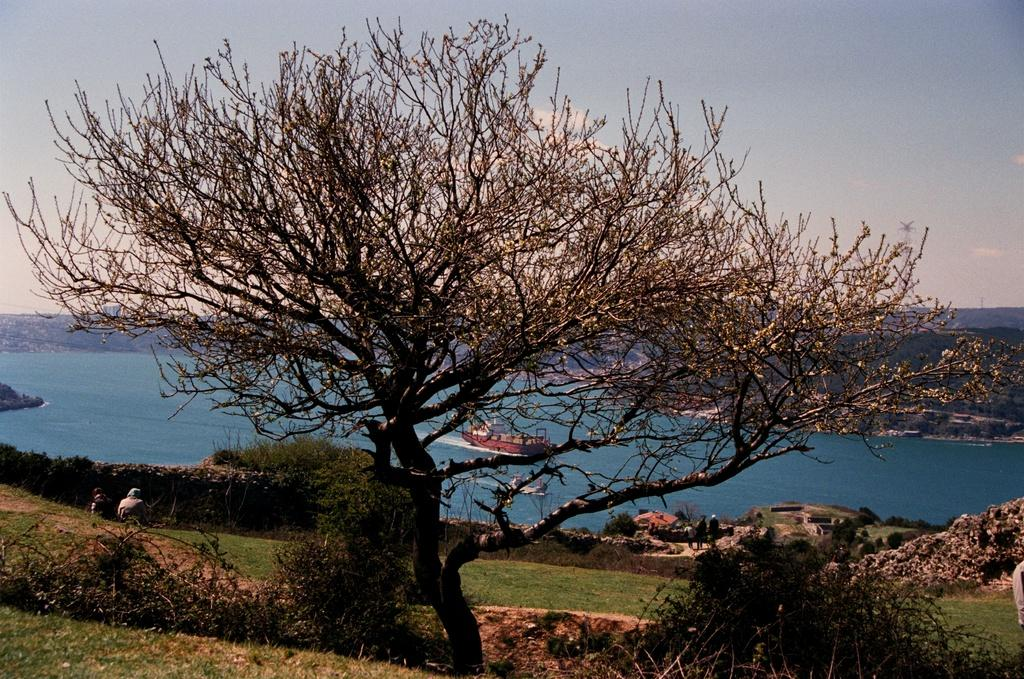What type of vegetation is present in the image? There is a tree, small bushes, and grass in the image. What are the people in the image doing? Two people are sitting, and three people are standing in the image. What is the main object in the image? There is a ship in the image. Is the ship moving or stationary? The ship is moving on the water in the image. What type of sticks are the people using to measure the distance between the tree and the ship? There are no sticks present in the image, nor is anyone measuring the distance between the tree and the ship. 